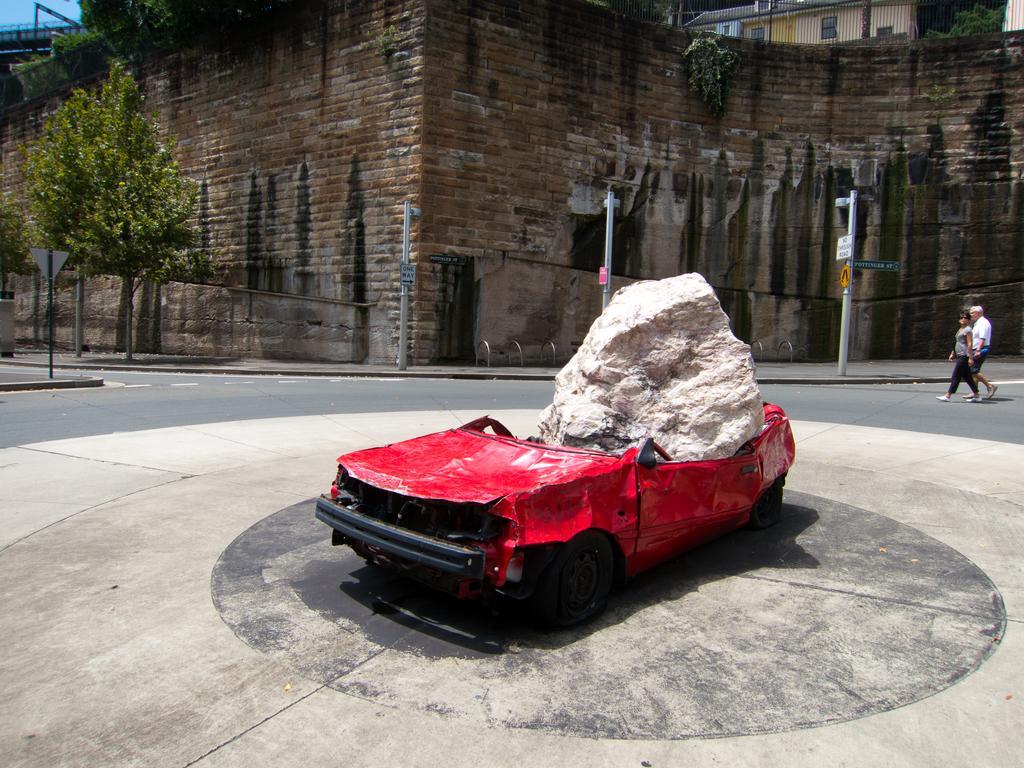How would you summarize this image in a sentence or two? In this image I can see a car which is red in color is damaged and I can see a huge rock which is cream in color on the car. I can see the road, two persons standing in the road, few trees which are green in color, few poles, few boards attached to the poles and the wall which is made of bricks which is black, brown and cream in color. I can see a building, few trees and the sky in the background. 